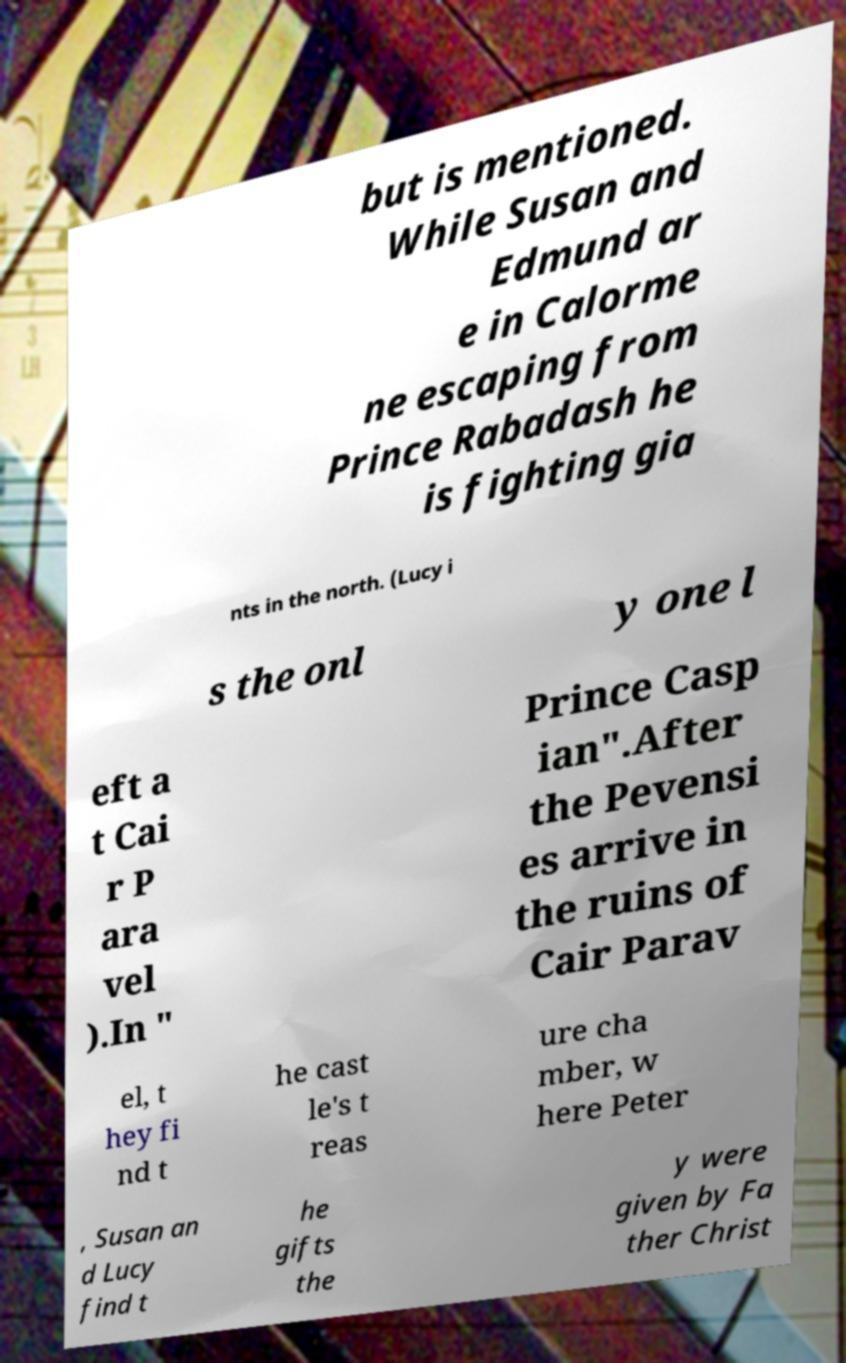Can you read and provide the text displayed in the image?This photo seems to have some interesting text. Can you extract and type it out for me? but is mentioned. While Susan and Edmund ar e in Calorme ne escaping from Prince Rabadash he is fighting gia nts in the north. (Lucy i s the onl y one l eft a t Cai r P ara vel ).In " Prince Casp ian".After the Pevensi es arrive in the ruins of Cair Parav el, t hey fi nd t he cast le's t reas ure cha mber, w here Peter , Susan an d Lucy find t he gifts the y were given by Fa ther Christ 